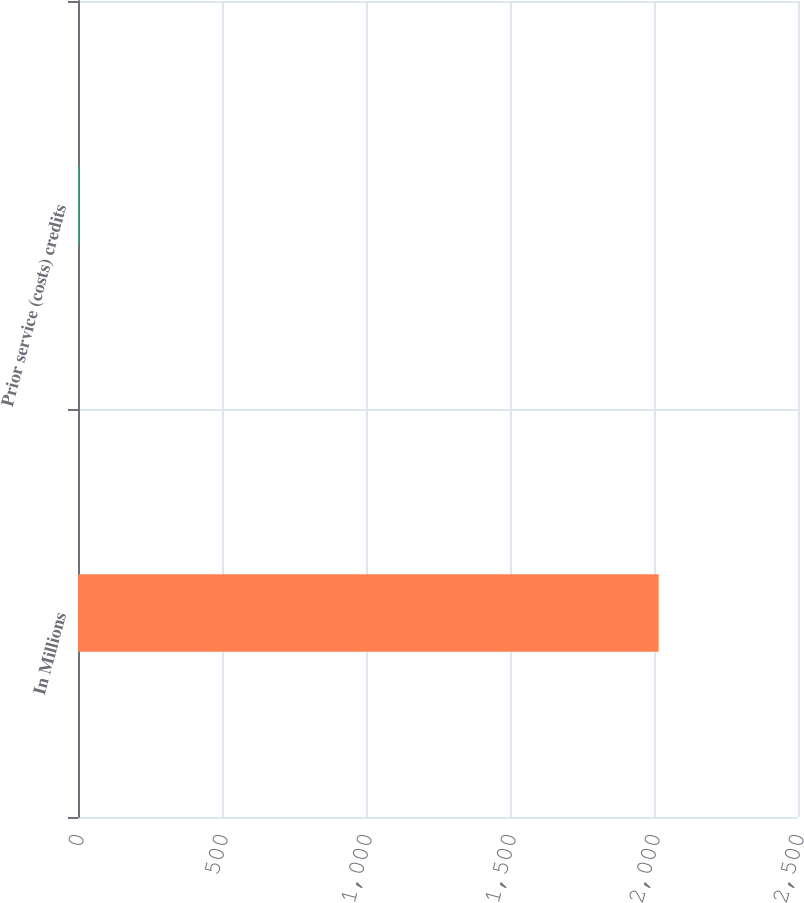Convert chart to OTSL. <chart><loc_0><loc_0><loc_500><loc_500><bar_chart><fcel>In Millions<fcel>Prior service (costs) credits<nl><fcel>2016<fcel>1.2<nl></chart> 